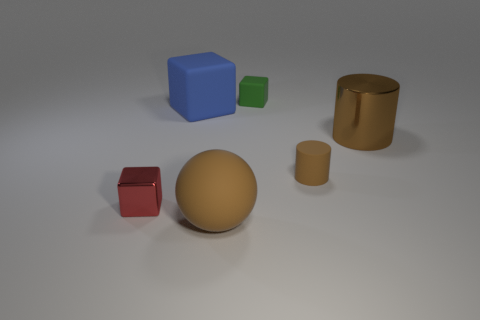Subtract all rubber blocks. How many blocks are left? 1 Subtract all red blocks. How many blocks are left? 2 Subtract 3 cubes. How many cubes are left? 0 Add 2 large yellow metallic balls. How many objects exist? 8 Subtract 0 red spheres. How many objects are left? 6 Subtract all cylinders. How many objects are left? 4 Subtract all brown cubes. Subtract all brown cylinders. How many cubes are left? 3 Subtract all cyan balls. How many blue blocks are left? 1 Subtract all blocks. Subtract all small rubber objects. How many objects are left? 1 Add 2 green things. How many green things are left? 3 